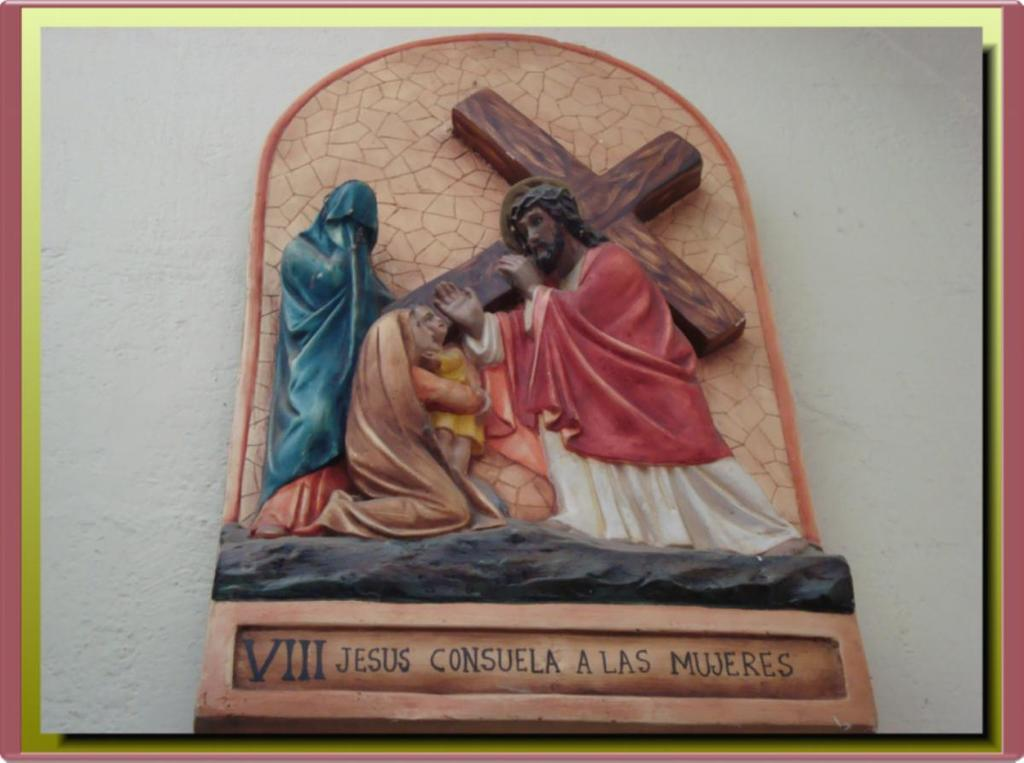<image>
Relay a brief, clear account of the picture shown. A carving of the crucifix and Jesus carrying the cross that says Jesus Consuela A Las Mujeres. 